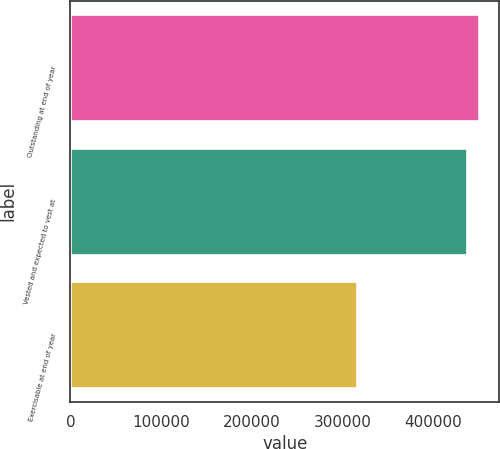<chart> <loc_0><loc_0><loc_500><loc_500><bar_chart><fcel>Outstanding at end of year<fcel>Vested and expected to vest at<fcel>Exercisable at end of year<nl><fcel>450049<fcel>437109<fcel>316341<nl></chart> 